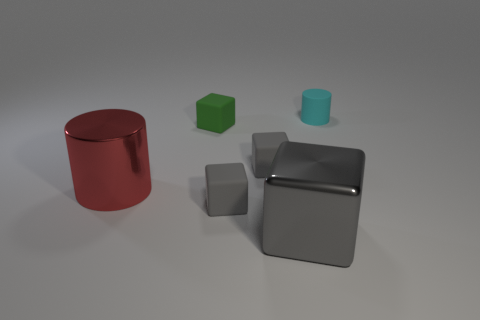Subtract all cyan cylinders. How many gray blocks are left? 3 Subtract all brown cubes. Subtract all green spheres. How many cubes are left? 4 Add 1 large gray shiny blocks. How many objects exist? 7 Subtract all blocks. How many objects are left? 2 Add 5 metal objects. How many metal objects are left? 7 Add 2 rubber blocks. How many rubber blocks exist? 5 Subtract 0 purple cylinders. How many objects are left? 6 Subtract all tiny green rubber things. Subtract all tiny green rubber blocks. How many objects are left? 4 